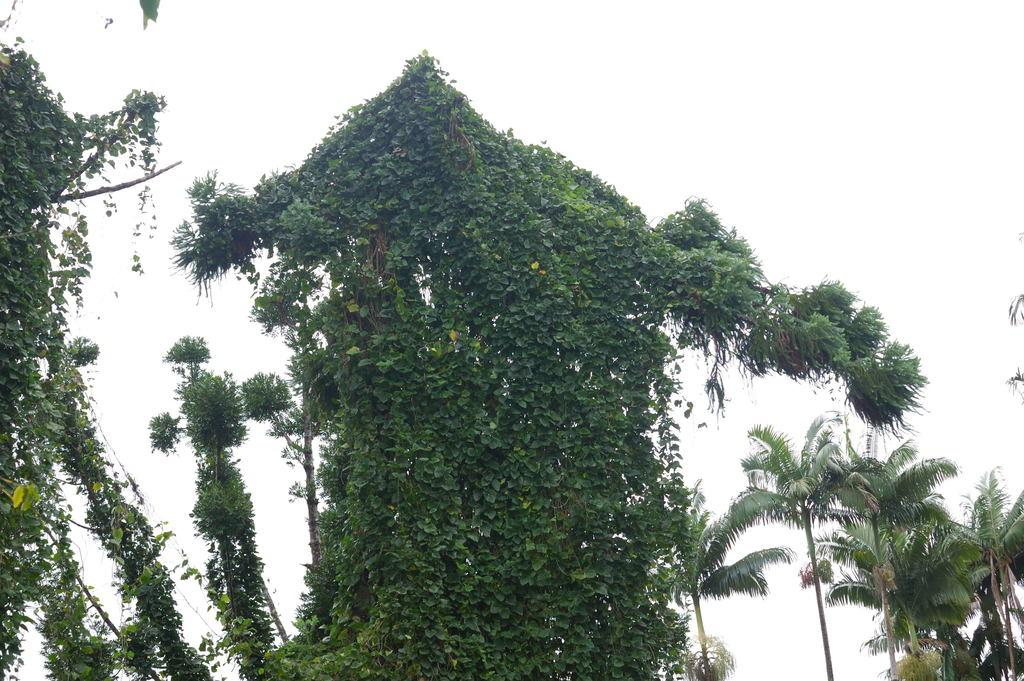What type of vegetation is present at the bottom of the image? There are trees at the bottom of the image. What can be seen in the background of the image? The sky is visible in the background of the image. What type of motion can be observed in the clouds in the image? There are no clouds present in the image, so motion cannot be observed in clouds. 